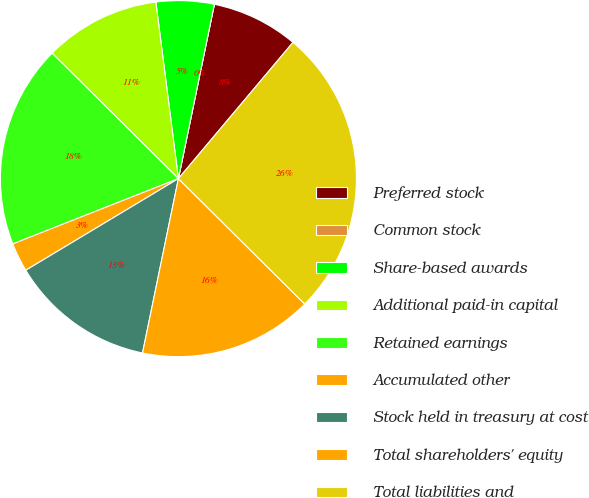Convert chart. <chart><loc_0><loc_0><loc_500><loc_500><pie_chart><fcel>Preferred stock<fcel>Common stock<fcel>Share-based awards<fcel>Additional paid-in capital<fcel>Retained earnings<fcel>Accumulated other<fcel>Stock held in treasury at cost<fcel>Total shareholders' equity<fcel>Total liabilities and<nl><fcel>7.89%<fcel>0.0%<fcel>5.26%<fcel>10.53%<fcel>18.42%<fcel>2.63%<fcel>13.16%<fcel>15.79%<fcel>26.31%<nl></chart> 